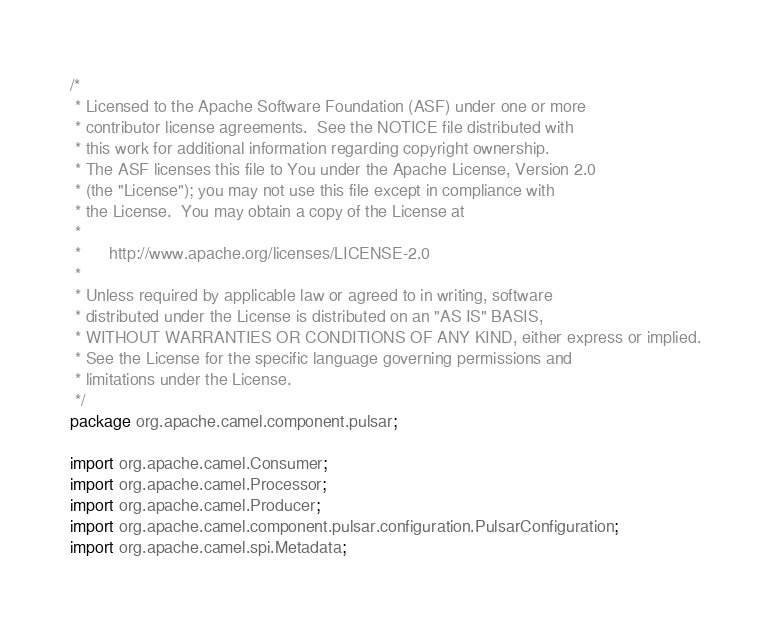<code> <loc_0><loc_0><loc_500><loc_500><_Java_>/*
 * Licensed to the Apache Software Foundation (ASF) under one or more
 * contributor license agreements.  See the NOTICE file distributed with
 * this work for additional information regarding copyright ownership.
 * The ASF licenses this file to You under the Apache License, Version 2.0
 * (the "License"); you may not use this file except in compliance with
 * the License.  You may obtain a copy of the License at
 *
 *      http://www.apache.org/licenses/LICENSE-2.0
 *
 * Unless required by applicable law or agreed to in writing, software
 * distributed under the License is distributed on an "AS IS" BASIS,
 * WITHOUT WARRANTIES OR CONDITIONS OF ANY KIND, either express or implied.
 * See the License for the specific language governing permissions and
 * limitations under the License.
 */
package org.apache.camel.component.pulsar;

import org.apache.camel.Consumer;
import org.apache.camel.Processor;
import org.apache.camel.Producer;
import org.apache.camel.component.pulsar.configuration.PulsarConfiguration;
import org.apache.camel.spi.Metadata;</code> 